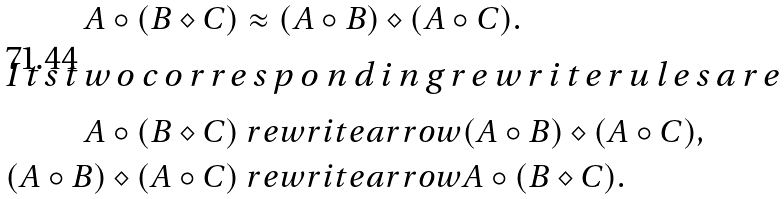Convert formula to latex. <formula><loc_0><loc_0><loc_500><loc_500>A \circ ( B \diamond C ) & \approx ( A \circ B ) \diamond ( A \circ C ) . \intertext { I t s t w o c o r r e s p o n d i n g r e w r i t e r u l e s a r e } A \circ ( B \diamond C ) & \ r e w r i t e a r r o w ( A \circ B ) \diamond ( A \circ C ) , \\ ( A \circ B ) \diamond ( A \circ C ) & \ r e w r i t e a r r o w A \circ ( B \diamond C ) .</formula> 